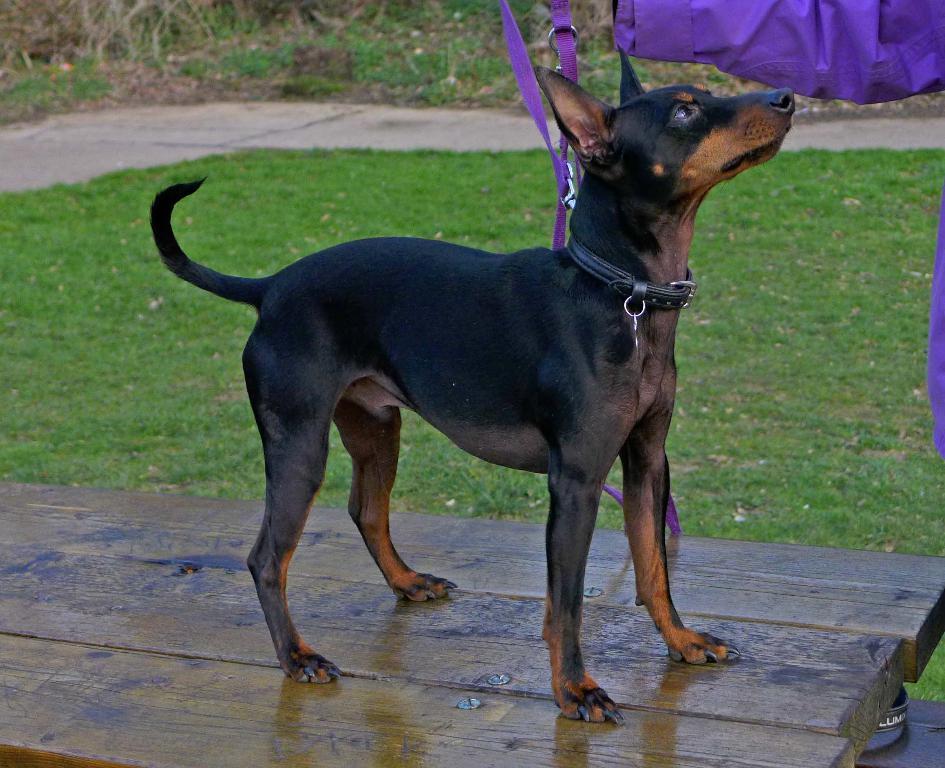In one or two sentences, can you explain what this image depicts? In this image, we can see a dog on the wooden surface. We can also see some cloth on the right side. We can see the ground. We can see some grass, plants. 